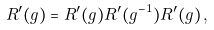Convert formula to latex. <formula><loc_0><loc_0><loc_500><loc_500>R ^ { \prime } ( g ) = R ^ { \prime } ( g ) R ^ { \prime } ( g ^ { - 1 } ) R ^ { \prime } ( g ) \, ,</formula> 